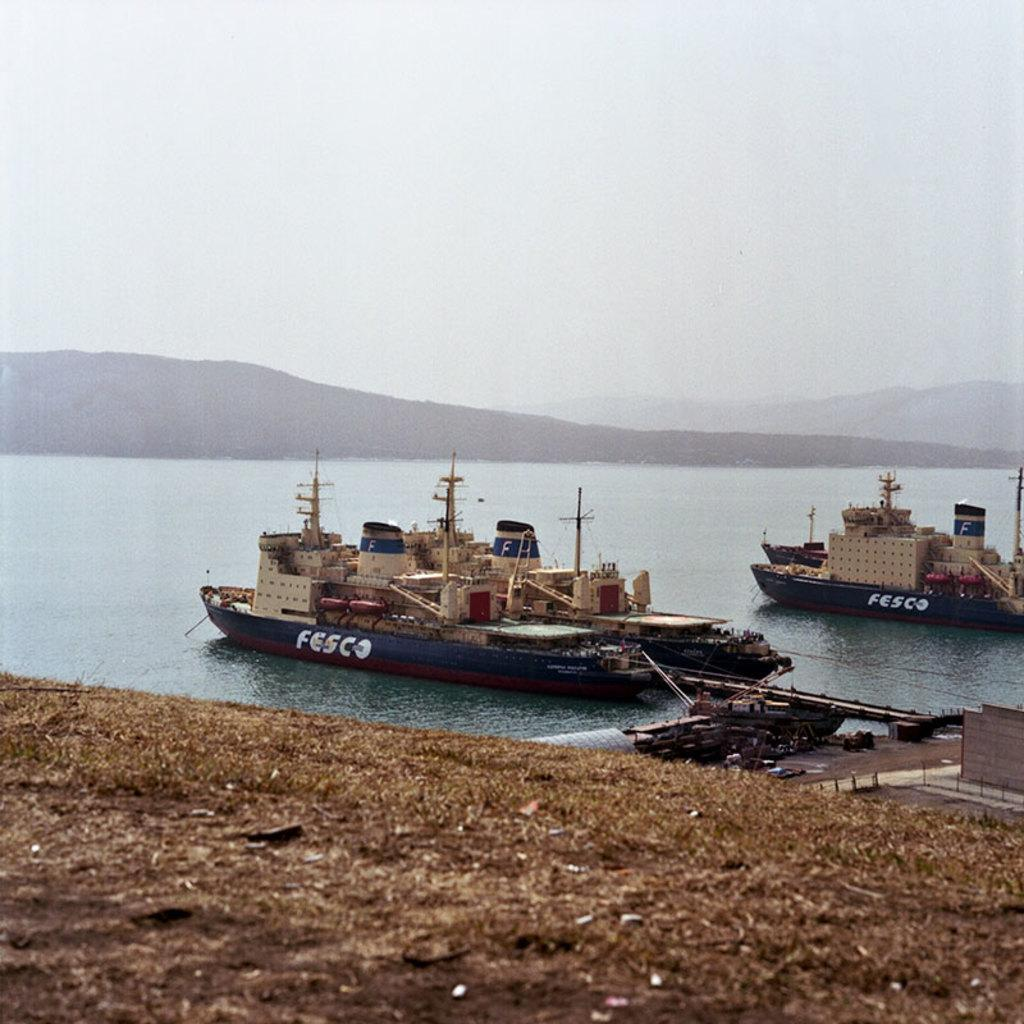<image>
Render a clear and concise summary of the photo. A couple of big boats, both of which say FESCO on the sides. 